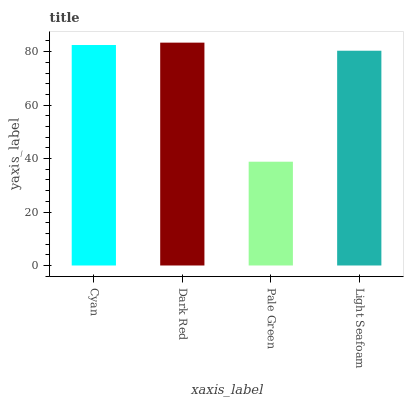Is Pale Green the minimum?
Answer yes or no. Yes. Is Dark Red the maximum?
Answer yes or no. Yes. Is Dark Red the minimum?
Answer yes or no. No. Is Pale Green the maximum?
Answer yes or no. No. Is Dark Red greater than Pale Green?
Answer yes or no. Yes. Is Pale Green less than Dark Red?
Answer yes or no. Yes. Is Pale Green greater than Dark Red?
Answer yes or no. No. Is Dark Red less than Pale Green?
Answer yes or no. No. Is Cyan the high median?
Answer yes or no. Yes. Is Light Seafoam the low median?
Answer yes or no. Yes. Is Pale Green the high median?
Answer yes or no. No. Is Cyan the low median?
Answer yes or no. No. 